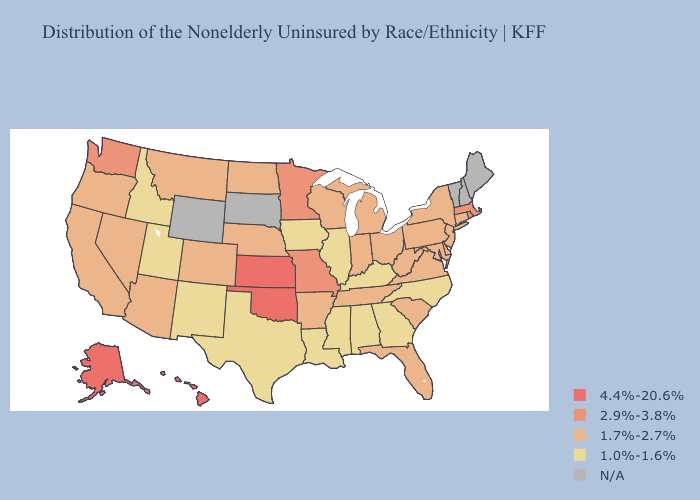Among the states that border New Mexico , does Oklahoma have the lowest value?
Answer briefly. No. Name the states that have a value in the range 2.9%-3.8%?
Answer briefly. Massachusetts, Minnesota, Missouri, Rhode Island, Washington. What is the highest value in the USA?
Short answer required. 4.4%-20.6%. What is the lowest value in the USA?
Answer briefly. 1.0%-1.6%. Is the legend a continuous bar?
Be succinct. No. How many symbols are there in the legend?
Give a very brief answer. 5. What is the lowest value in the MidWest?
Short answer required. 1.0%-1.6%. What is the value of Texas?
Give a very brief answer. 1.0%-1.6%. What is the value of Nebraska?
Concise answer only. 1.7%-2.7%. 